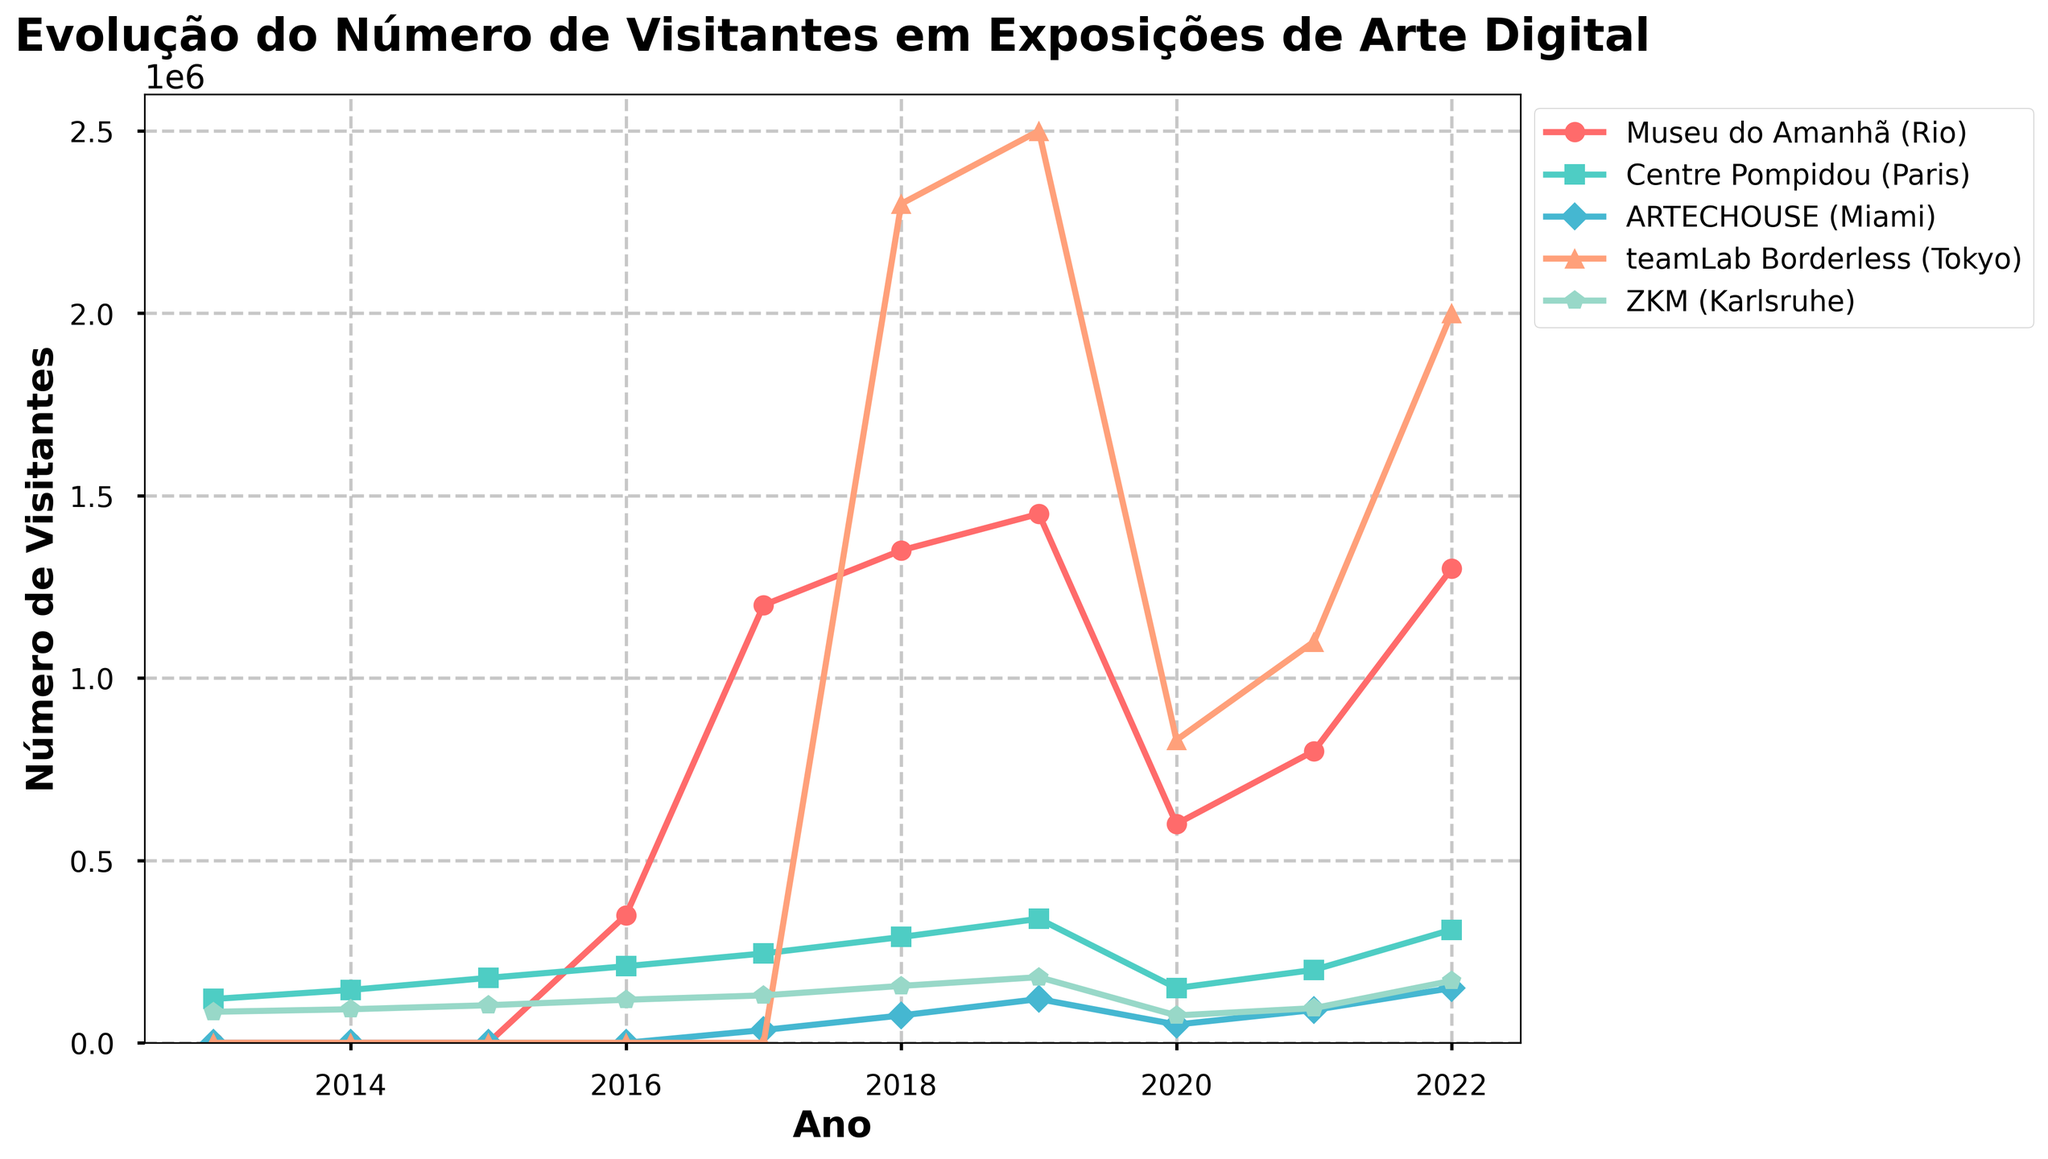What year did the Museu do Amanhã (Rio) have the highest number of visitors? The year 2019 shows the highest peak on the graph for Museu do Amanhã (Rio). By comparing the heights of the points, 2019 stands out.
Answer: 2019 What was the total number of visitors for Centre Pompidou (Paris) over the last 10 years? Sum the number of visitors from 2013 to 2022 for Centre Pompidou (Paris): 120000 + 145000 + 178000 + 210000 + 245000 + 290000 + 340000 + 150000 + 200000 + 310000 = 2188000.
Answer: 2188000 Which museum had the largest increase in visitors between 2019 and 2020? Compare the difference in the number of visitors from 2019 to 2020 for each museum: Museu do Amanhã (Rio) (1450000 - 600000 = 850000), Centre Pompidou (Paris) (340000 - 150000 = 190000), ARTECHOUSE (Miami) (120000 - 50000 = 70000), teamLab Borderless (Tokyo) (2500000 - 830000 = 1670000), and ZKM (Karlsruhe) (180000 - 75000 = 105000). The largest difference is seen in teamLab Borderless (Tokyo) with 1670000.
Answer: teamLab Borderless (Tokyo) What were the visitor numbers for ARTECHOUSE (Miami) in 2017 and 2018? Locate the points on the graph corresponding to ARTECHOUSE (Miami) for 2017 and 2018 and read off the values: 35000 (2017) and 75000 (2018).
Answer: 35000 in 2017, 75000 in 2018 Which museum had the most consistent growth in terms of visitors over the 10 years? Analyze each museum's trend line for steadiness without sharp increases or decreases. Centre Pompidou (Paris) shows a relatively steady increase in visitor numbers every year.
Answer: Centre Pompidou (Paris) What is the average number of visitors at teamLab Borderless (Tokyo) from 2018 to 2022? Calculate the average by adding the number of visitors from 2018 to 2022 and divide by the number of years. (2300000 + 2500000 + 830000 + 1100000 + 2000000) / 5 = 8730000 / 5 = 1746000.
Answer: 1746000 In which year did ZKM (Karlsruhe) surpass 150000 visitors for the first time? Identify the first year where the visitor number for ZKM (Karlsruhe) exceeds 150000 by analyzing the trend line and marked points: 156000 in 2018 is the first instance.
Answer: 2018 In 2020, which museum had the lowest number of visitors? Locate the point on the graph for 2020 and compare the heights. The lowest point corresponds to ZKM (Karlsruhe) with 75000 visitors.
Answer: ZKM (Karlsruhe) From 2013 to 2016, which museums had no visitors? Check the visitor numbers from 2013 to 2016 in the data provided. ARTECHOUSE (Miami) and teamLab Borderless (Tokyo) have zero visitors in those years.
Answer: ARTECHOUSE (Miami), teamLab Borderless (Tokyo) How many visitors did the Musée do Amanhã (Rio) gain between 2021 and 2022? Subtract the number of visitors in 2021 from the number of visitors in 2022 for Museu do Amanhã (Rio): 1300000 - 800000 = 500000.
Answer: 500000 